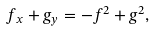<formula> <loc_0><loc_0><loc_500><loc_500>f _ { x } + g _ { y } = - f ^ { 2 } + g ^ { 2 } ,</formula> 